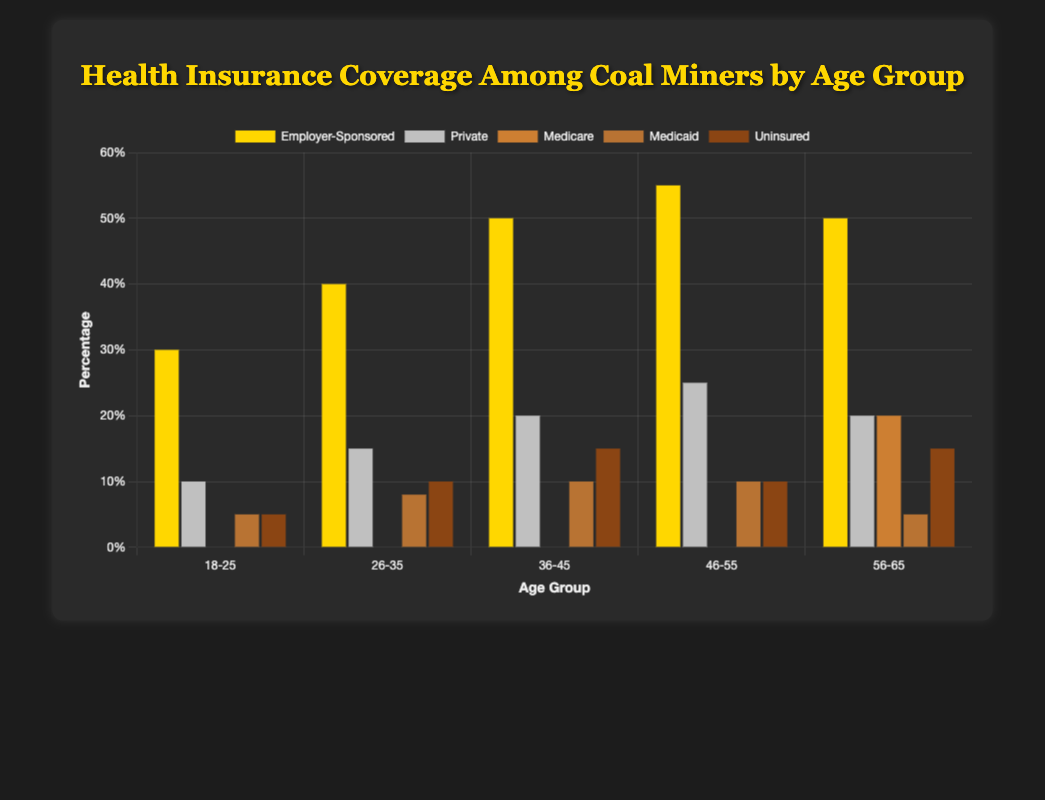Which age group has the highest percentage of employer-sponsored health insurance coverage? The age group with the highest percentage of employer-sponsored health insurance can be identified by finding the tallest bar labeled "Employer-Sponsored." The "46-55" age group has the highest percentage at 55%.
Answer: 46-55 Which insurance type covers the least number of miners aged 26-35? We need to find the smallest bar within the "26-35" age group, which corresponds to the insurance type. The "Medicare" bar is the smallest with 0%.
Answer: Medicare Among the age groups of 46-55 and 56-65, which one has a higher percentage of Medicare coverage? Comparing the height of the "Medicare" bars between the "46-55" and "56-65" age groups, the "56-65" age group has a higher percentage at 20%, as the "46-55" group has 0%.
Answer: 56-65 What is the combined percentage of uninsured miners in the age groups 18-25 and 36-45? Adding the "Uninsured" percentages for "18-25" (5%) and "36-45" (15%) gives us 5% + 15% = 20%.
Answer: 20% How many more miners aged 36-45 have employer-sponsored insurance compared to those aged 26-35? Subtracting the "Employer-Sponsored" percentage for "26-35" (40%) from "36-45" (50%) gives us 50% - 40% = 10%.
Answer: 10% Which age group has the greatest variety in percentages of different insurance types? The age group with the greatest variety will have the widest range between the highest and lowest percentages for its insurance types. For "46-55," the range is 55% to 0%, and for "56-65," the range is 50% to 5%, etc. The "56-65" group has the widest range (50% - 5% = 45%).
Answer: 56-65 What is the average percentage of private insurance coverage across all age groups? Sum the "Private" percentages for all age groups (10% + 15% + 20% + 25% + 20%) and divide by the number of age groups, 5. Total sum is 90%, so the average is 90% / 5 = 18%.
Answer: 18% What percentage of miners aged 56-65 are either covered by Medicare or uninsured? Adding the "Medicare" (20%) and "Uninsured" (15%) percentages for the "56-65" age group gives us 20% + 15% = 35%.
Answer: 35% Which insurance type sees the biggest increase in coverage from the 18-25 age group to the 26-35 age group? Comparing the differences in each insurance type’s coverage between the "18-25" and "26-35" age groups, the biggest increase is in "Employer-Sponsored" insurance (40% - 30% = 10%).
Answer: Employer-Sponsored 